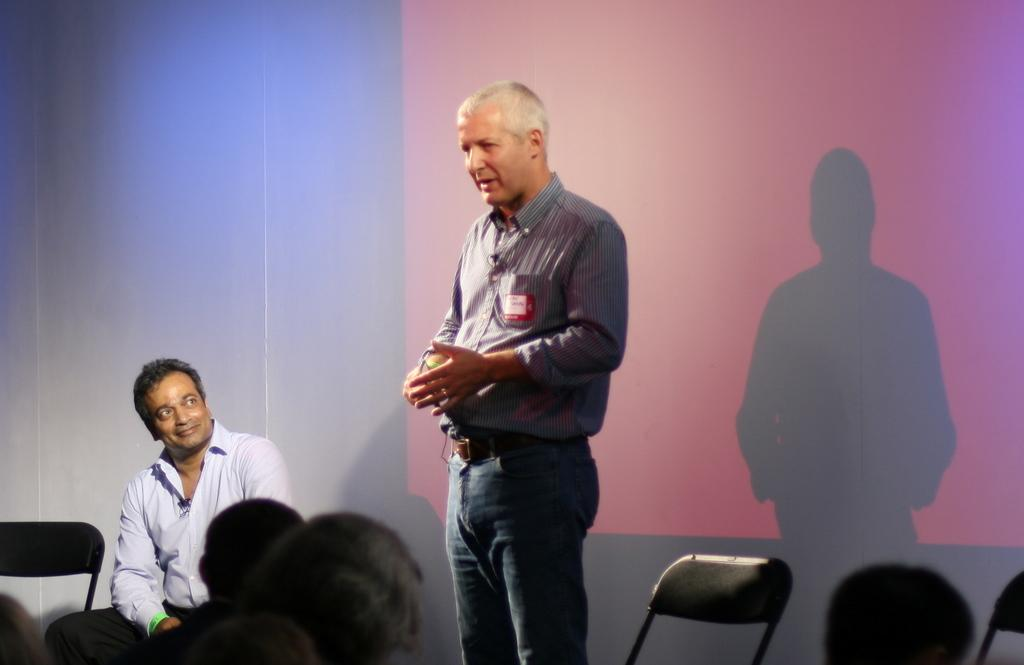What is the primary action of the man in the image? The man is speaking in the image. Can you describe the position of the other person in the image? There is another person sitting in the image. What can be seen in the background of the image? There is a wall in the background of the image. How many fifths are present in the image? There is no mention of a "fifth" in the image, so it cannot be determined how many there are. 